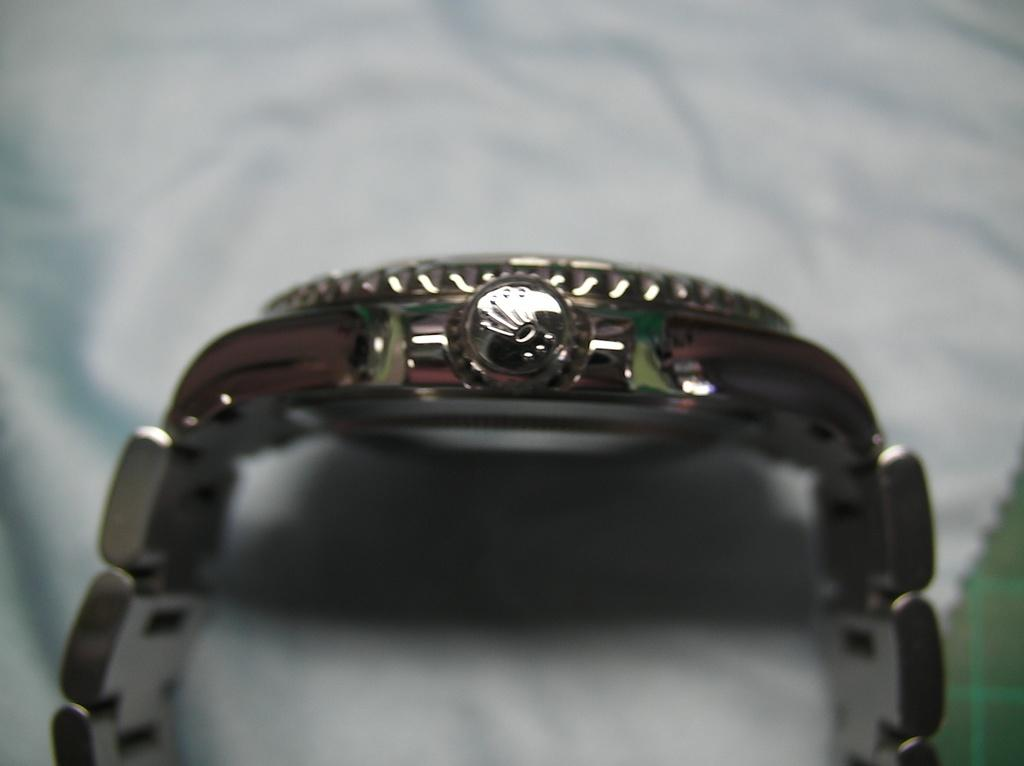What object is the main focus of the image? There is a watch in the image. What is the color of the watch? The watch is silver in color. What is the watch placed on in the image? The watch is on a white surface. How many legs does the doll have in the image? There is no doll present in the image, so it is not possible to determine the number of legs it might have. 